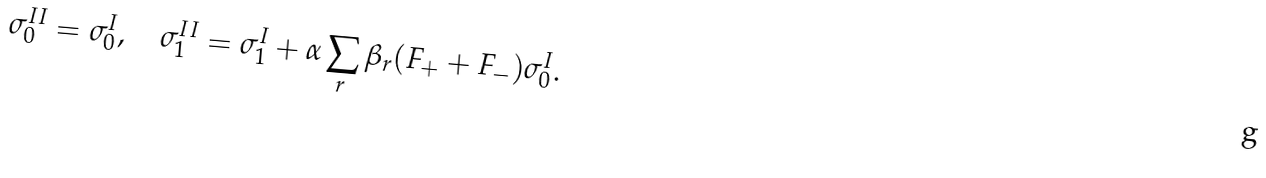Convert formula to latex. <formula><loc_0><loc_0><loc_500><loc_500>\sigma ^ { I I } _ { 0 } = \sigma ^ { I } _ { 0 } , \quad \sigma ^ { I I } _ { 1 } = \sigma ^ { I } _ { 1 } + \alpha \sum _ { r } \beta _ { r } ( F _ { + } + F _ { - } ) \sigma ^ { I } _ { 0 } .</formula> 